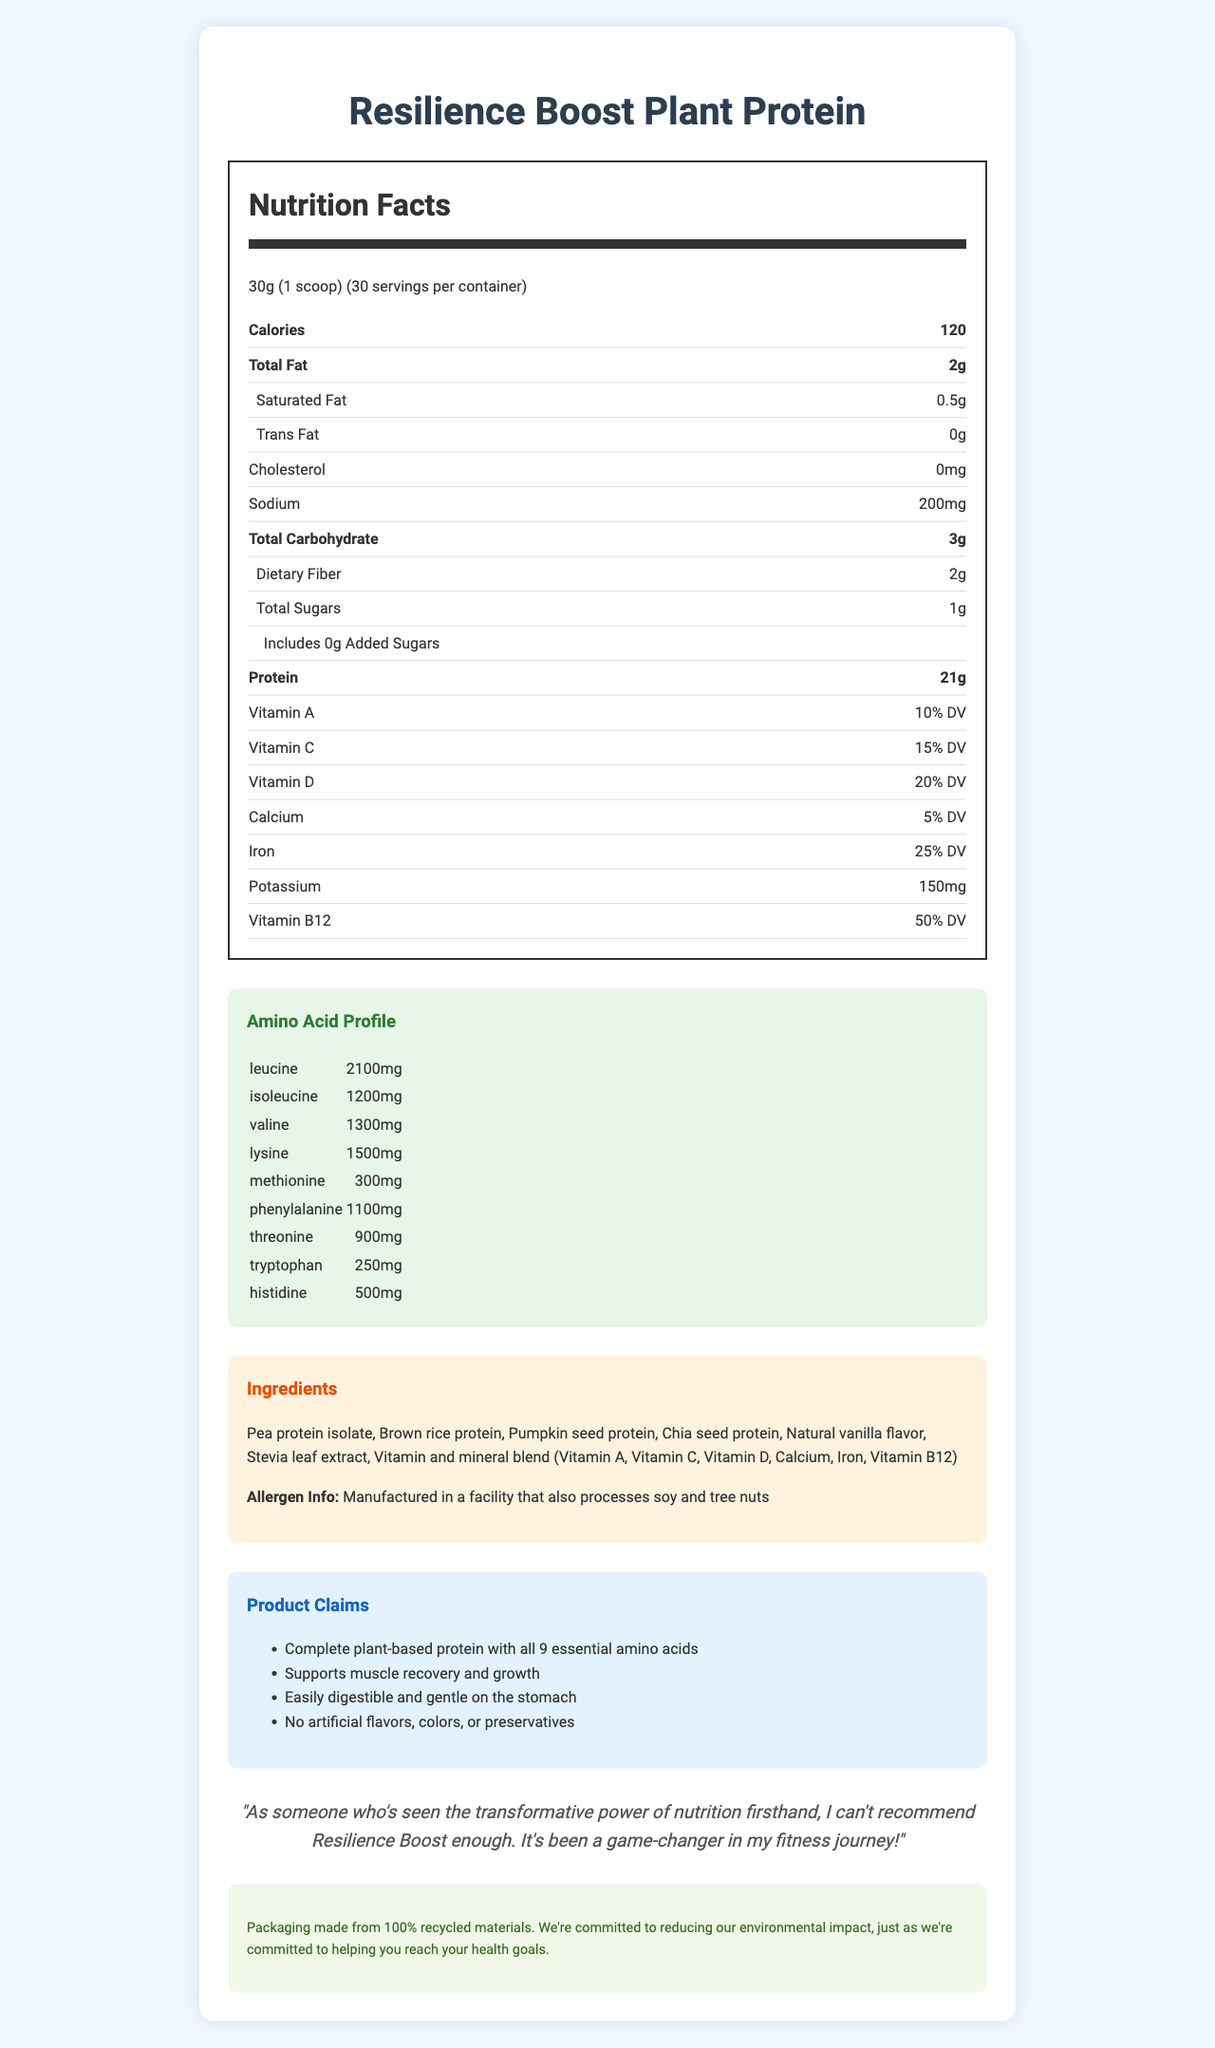what is the serving size? The serving size is mentioned at the beginning of the Nutrition Facts section as "30g (1 scoop)".
Answer: 30g (1 scoop) how many servings are in a container? The number of servings per container is stated right after the serving size as "30 servings per container".
Answer: 30 what is the amount of protein per serving? The amount of protein per serving is shown in the Nutrition Facts table as "Protein - 21g".
Answer: 21g how much dietary fiber is in each serving? Dietary fiber is listed under total carbohydrates in the Nutrition Facts table: "Dietary Fiber - 2g".
Answer: 2g how much iron is in each serving? The amount of iron per serving is specified in the Nutrition Facts table as "Iron - 25% DV".
Answer: 25% DV what are the main ingredients of this product? The ingredients are listed under the Ingredients section.
Answer: Pea protein isolate, Brown rice protein, Pumpkin seed protein, Chia seed protein, Natural vanilla flavor, Stevia leaf extract, Vitamin and mineral blend (Vitamin A, Vitamin C, Vitamin D, Calcium, Iron, Vitamin B12) what is the total fat per serving? A. 1g B. 2g C. 3g D. 0.5g Total fat per serving is indicated in the Nutrition Facts table as "Total Fat - 2g".
Answer: B. 2g which of the following vitamins has the highest daily value percentage per serving? A. Vitamin A B. Vitamin C C. Vitamin D D. Vitamin B12 Vitamin B12 has the highest percentage at 50% DV, as mentioned in the Nutrition Facts table.
Answer: D. Vitamin B12 is the product cholesterol-free? The nutrition facts state "Cholesterol - 0mg", indicating the product is cholesterol-free.
Answer: Yes what is the sodium content per serving? Sodium content per serving is indicated in the Nutrition Facts table as "Sodium - 200mg".
Answer: 200mg summarize the main features of Resilience Boost Plant Protein. The document provides detailed nutrition facts, including protein, vitamin content, and amino acid profile. It highlights that the product supports muscle recovery, is easily digestible, and is gentle on the stomach. Sustainability and allergen information are also featured.
Answer: Resilience Boost Plant Protein is a plant-based protein powder with 21g of protein per serving, containing all 9 essential amino acids. It also includes added vitamins such as Vitamin A, C, D, and B12. The product is free from artificial flavors, colors, or preservatives and is made from ingredients like pea protein isolate, brown rice protein, and chia seed protein. Each serving is low in fat and high in dietary fiber, and the product comes in eco-friendly packaging made from recycled materials. which of the following is NOT a claim made by the product? A. Supports muscle recovery and growth B. Contains artificial flavors C. Easily digestible D. Complete plant-based protein The claims section explicitly mentions that the product has no artificial flavors, colors, or preservatives.
Answer: B. Contains artificial flavors where is the product manufactured? The document does not provide information about the manufacturing location of the product.
Answer: Not enough information 